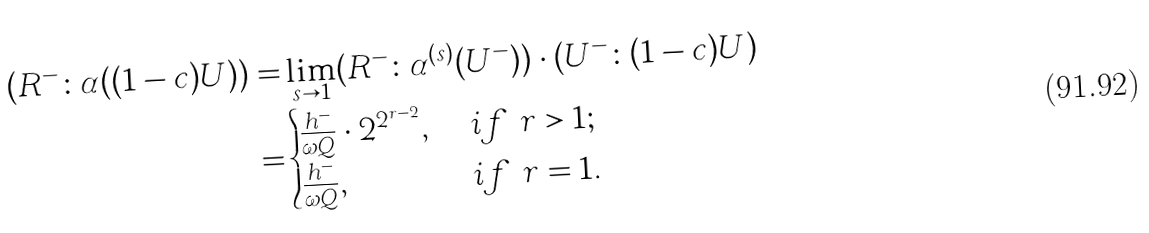Convert formula to latex. <formula><loc_0><loc_0><loc_500><loc_500>( R ^ { - } \colon \alpha ( ( 1 - c ) U ) ) = & \lim _ { s \rightarrow 1 } ( R ^ { - } \colon \alpha ^ { ( s ) } ( U ^ { - } ) ) \cdot ( U ^ { - } \colon ( 1 - c ) U ) \\ = & \begin{cases} \frac { h ^ { - } } { \omega Q } \cdot 2 ^ { 2 ^ { r - 2 } } , \ & i f \ r > 1 ; \\ \frac { h ^ { - } } { \omega Q } , \ & i f \ r = 1 . \end{cases}</formula> 